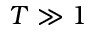<formula> <loc_0><loc_0><loc_500><loc_500>T \gg 1</formula> 